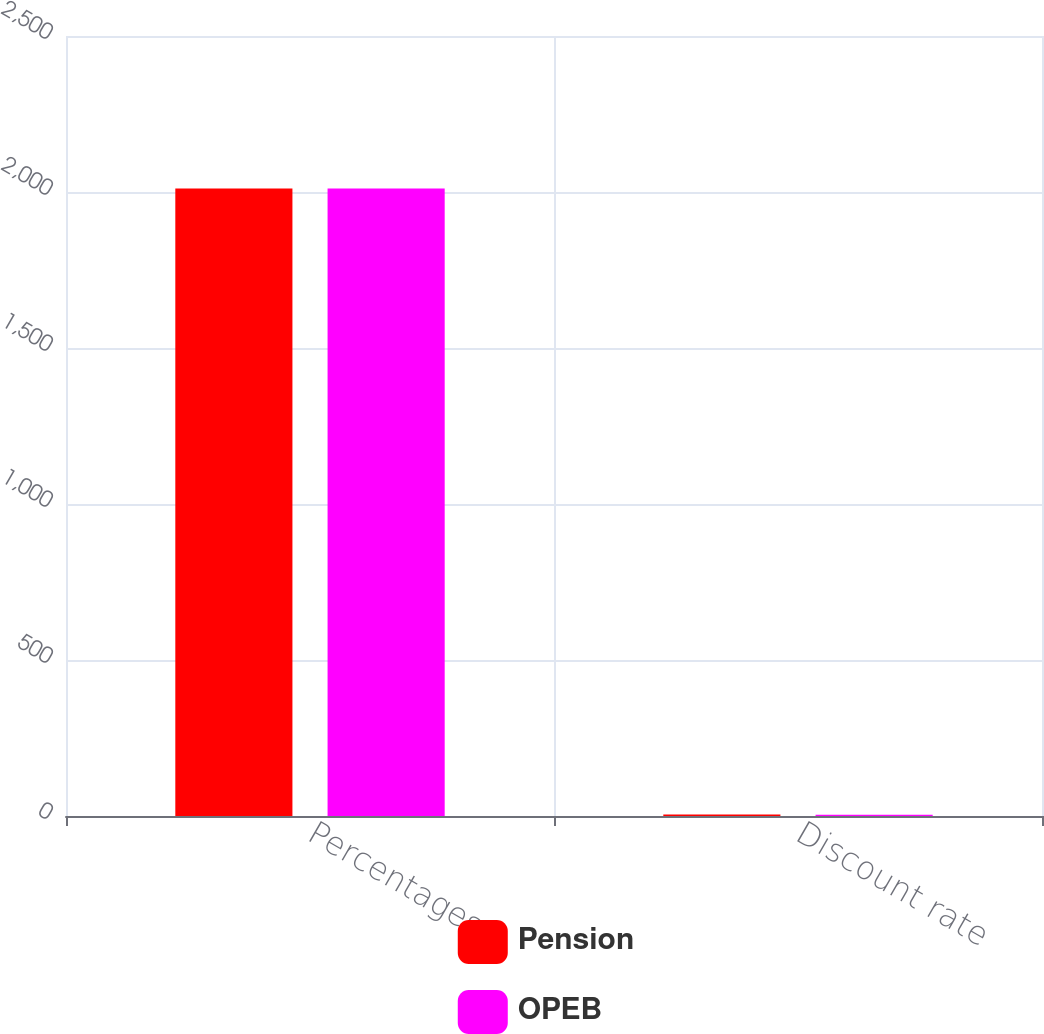Convert chart to OTSL. <chart><loc_0><loc_0><loc_500><loc_500><stacked_bar_chart><ecel><fcel>Percentages<fcel>Discount rate<nl><fcel>Pension<fcel>2011<fcel>4.54<nl><fcel>OPEB<fcel>2011<fcel>4.36<nl></chart> 